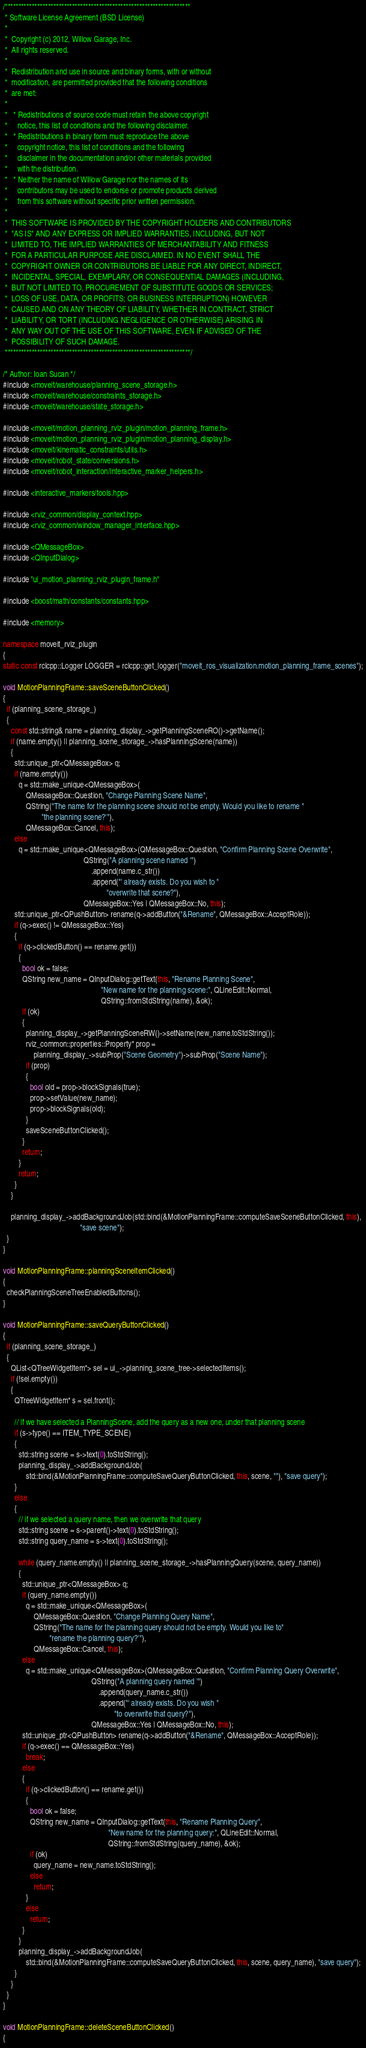<code> <loc_0><loc_0><loc_500><loc_500><_C++_>/*********************************************************************
 * Software License Agreement (BSD License)
 *
 *  Copyright (c) 2012, Willow Garage, Inc.
 *  All rights reserved.
 *
 *  Redistribution and use in source and binary forms, with or without
 *  modification, are permitted provided that the following conditions
 *  are met:
 *
 *   * Redistributions of source code must retain the above copyright
 *     notice, this list of conditions and the following disclaimer.
 *   * Redistributions in binary form must reproduce the above
 *     copyright notice, this list of conditions and the following
 *     disclaimer in the documentation and/or other materials provided
 *     with the distribution.
 *   * Neither the name of Willow Garage nor the names of its
 *     contributors may be used to endorse or promote products derived
 *     from this software without specific prior written permission.
 *
 *  THIS SOFTWARE IS PROVIDED BY THE COPYRIGHT HOLDERS AND CONTRIBUTORS
 *  "AS IS" AND ANY EXPRESS OR IMPLIED WARRANTIES, INCLUDING, BUT NOT
 *  LIMITED TO, THE IMPLIED WARRANTIES OF MERCHANTABILITY AND FITNESS
 *  FOR A PARTICULAR PURPOSE ARE DISCLAIMED. IN NO EVENT SHALL THE
 *  COPYRIGHT OWNER OR CONTRIBUTORS BE LIABLE FOR ANY DIRECT, INDIRECT,
 *  INCIDENTAL, SPECIAL, EXEMPLARY, OR CONSEQUENTIAL DAMAGES (INCLUDING,
 *  BUT NOT LIMITED TO, PROCUREMENT OF SUBSTITUTE GOODS OR SERVICES;
 *  LOSS OF USE, DATA, OR PROFITS; OR BUSINESS INTERRUPTION) HOWEVER
 *  CAUSED AND ON ANY THEORY OF LIABILITY, WHETHER IN CONTRACT, STRICT
 *  LIABILITY, OR TORT (INCLUDING NEGLIGENCE OR OTHERWISE) ARISING IN
 *  ANY WAY OUT OF THE USE OF THIS SOFTWARE, EVEN IF ADVISED OF THE
 *  POSSIBILITY OF SUCH DAMAGE.
 *********************************************************************/

/* Author: Ioan Sucan */
#include <moveit/warehouse/planning_scene_storage.h>
#include <moveit/warehouse/constraints_storage.h>
#include <moveit/warehouse/state_storage.h>

#include <moveit/motion_planning_rviz_plugin/motion_planning_frame.h>
#include <moveit/motion_planning_rviz_plugin/motion_planning_display.h>
#include <moveit/kinematic_constraints/utils.h>
#include <moveit/robot_state/conversions.h>
#include <moveit/robot_interaction/interactive_marker_helpers.h>

#include <interactive_markers/tools.hpp>

#include <rviz_common/display_context.hpp>
#include <rviz_common/window_manager_interface.hpp>

#include <QMessageBox>
#include <QInputDialog>

#include "ui_motion_planning_rviz_plugin_frame.h"

#include <boost/math/constants/constants.hpp>

#include <memory>

namespace moveit_rviz_plugin
{
static const rclcpp::Logger LOGGER = rclcpp::get_logger("moveit_ros_visualization.motion_planning_frame_scenes");

void MotionPlanningFrame::saveSceneButtonClicked()
{
  if (planning_scene_storage_)
  {
    const std::string& name = planning_display_->getPlanningSceneRO()->getName();
    if (name.empty() || planning_scene_storage_->hasPlanningScene(name))
    {
      std::unique_ptr<QMessageBox> q;
      if (name.empty())
        q = std::make_unique<QMessageBox>(
            QMessageBox::Question, "Change Planning Scene Name",
            QString("The name for the planning scene should not be empty. Would you like to rename "
                    "the planning scene?'"),
            QMessageBox::Cancel, this);
      else
        q = std::make_unique<QMessageBox>(QMessageBox::Question, "Confirm Planning Scene Overwrite",
                                          QString("A planning scene named '")
                                              .append(name.c_str())
                                              .append("' already exists. Do you wish to "
                                                      "overwrite that scene?"),
                                          QMessageBox::Yes | QMessageBox::No, this);
      std::unique_ptr<QPushButton> rename(q->addButton("&Rename", QMessageBox::AcceptRole));
      if (q->exec() != QMessageBox::Yes)
      {
        if (q->clickedButton() == rename.get())
        {
          bool ok = false;
          QString new_name = QInputDialog::getText(this, "Rename Planning Scene",
                                                   "New name for the planning scene:", QLineEdit::Normal,
                                                   QString::fromStdString(name), &ok);
          if (ok)
          {
            planning_display_->getPlanningSceneRW()->setName(new_name.toStdString());
            rviz_common::properties::Property* prop =
                planning_display_->subProp("Scene Geometry")->subProp("Scene Name");
            if (prop)
            {
              bool old = prop->blockSignals(true);
              prop->setValue(new_name);
              prop->blockSignals(old);
            }
            saveSceneButtonClicked();
          }
          return;
        }
        return;
      }
    }

    planning_display_->addBackgroundJob(std::bind(&MotionPlanningFrame::computeSaveSceneButtonClicked, this),
                                        "save scene");
  }
}

void MotionPlanningFrame::planningSceneItemClicked()
{
  checkPlanningSceneTreeEnabledButtons();
}

void MotionPlanningFrame::saveQueryButtonClicked()
{
  if (planning_scene_storage_)
  {
    QList<QTreeWidgetItem*> sel = ui_->planning_scene_tree->selectedItems();
    if (!sel.empty())
    {
      QTreeWidgetItem* s = sel.front();

      // if we have selected a PlanningScene, add the query as a new one, under that planning scene
      if (s->type() == ITEM_TYPE_SCENE)
      {
        std::string scene = s->text(0).toStdString();
        planning_display_->addBackgroundJob(
            std::bind(&MotionPlanningFrame::computeSaveQueryButtonClicked, this, scene, ""), "save query");
      }
      else
      {
        // if we selected a query name, then we overwrite that query
        std::string scene = s->parent()->text(0).toStdString();
        std::string query_name = s->text(0).toStdString();

        while (query_name.empty() || planning_scene_storage_->hasPlanningQuery(scene, query_name))
        {
          std::unique_ptr<QMessageBox> q;
          if (query_name.empty())
            q = std::make_unique<QMessageBox>(
                QMessageBox::Question, "Change Planning Query Name",
                QString("The name for the planning query should not be empty. Would you like to"
                        "rename the planning query?'"),
                QMessageBox::Cancel, this);
          else
            q = std::make_unique<QMessageBox>(QMessageBox::Question, "Confirm Planning Query Overwrite",
                                              QString("A planning query named '")
                                                  .append(query_name.c_str())
                                                  .append("' already exists. Do you wish "
                                                          "to overwrite that query?"),
                                              QMessageBox::Yes | QMessageBox::No, this);
          std::unique_ptr<QPushButton> rename(q->addButton("&Rename", QMessageBox::AcceptRole));
          if (q->exec() == QMessageBox::Yes)
            break;
          else
          {
            if (q->clickedButton() == rename.get())
            {
              bool ok = false;
              QString new_name = QInputDialog::getText(this, "Rename Planning Query",
                                                       "New name for the planning query:", QLineEdit::Normal,
                                                       QString::fromStdString(query_name), &ok);
              if (ok)
                query_name = new_name.toStdString();
              else
                return;
            }
            else
              return;
          }
        }
        planning_display_->addBackgroundJob(
            std::bind(&MotionPlanningFrame::computeSaveQueryButtonClicked, this, scene, query_name), "save query");
      }
    }
  }
}

void MotionPlanningFrame::deleteSceneButtonClicked()
{</code> 